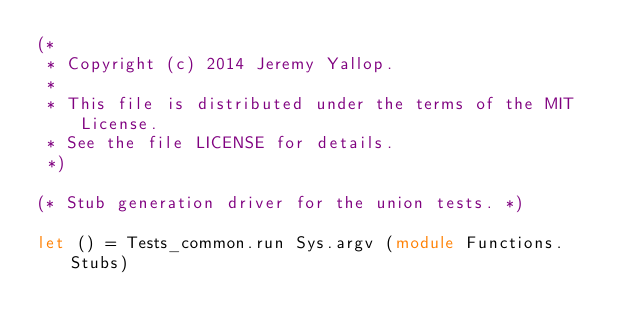Convert code to text. <code><loc_0><loc_0><loc_500><loc_500><_OCaml_>(*
 * Copyright (c) 2014 Jeremy Yallop.
 *
 * This file is distributed under the terms of the MIT License.
 * See the file LICENSE for details.
 *)

(* Stub generation driver for the union tests. *)

let () = Tests_common.run Sys.argv (module Functions.Stubs)
</code> 